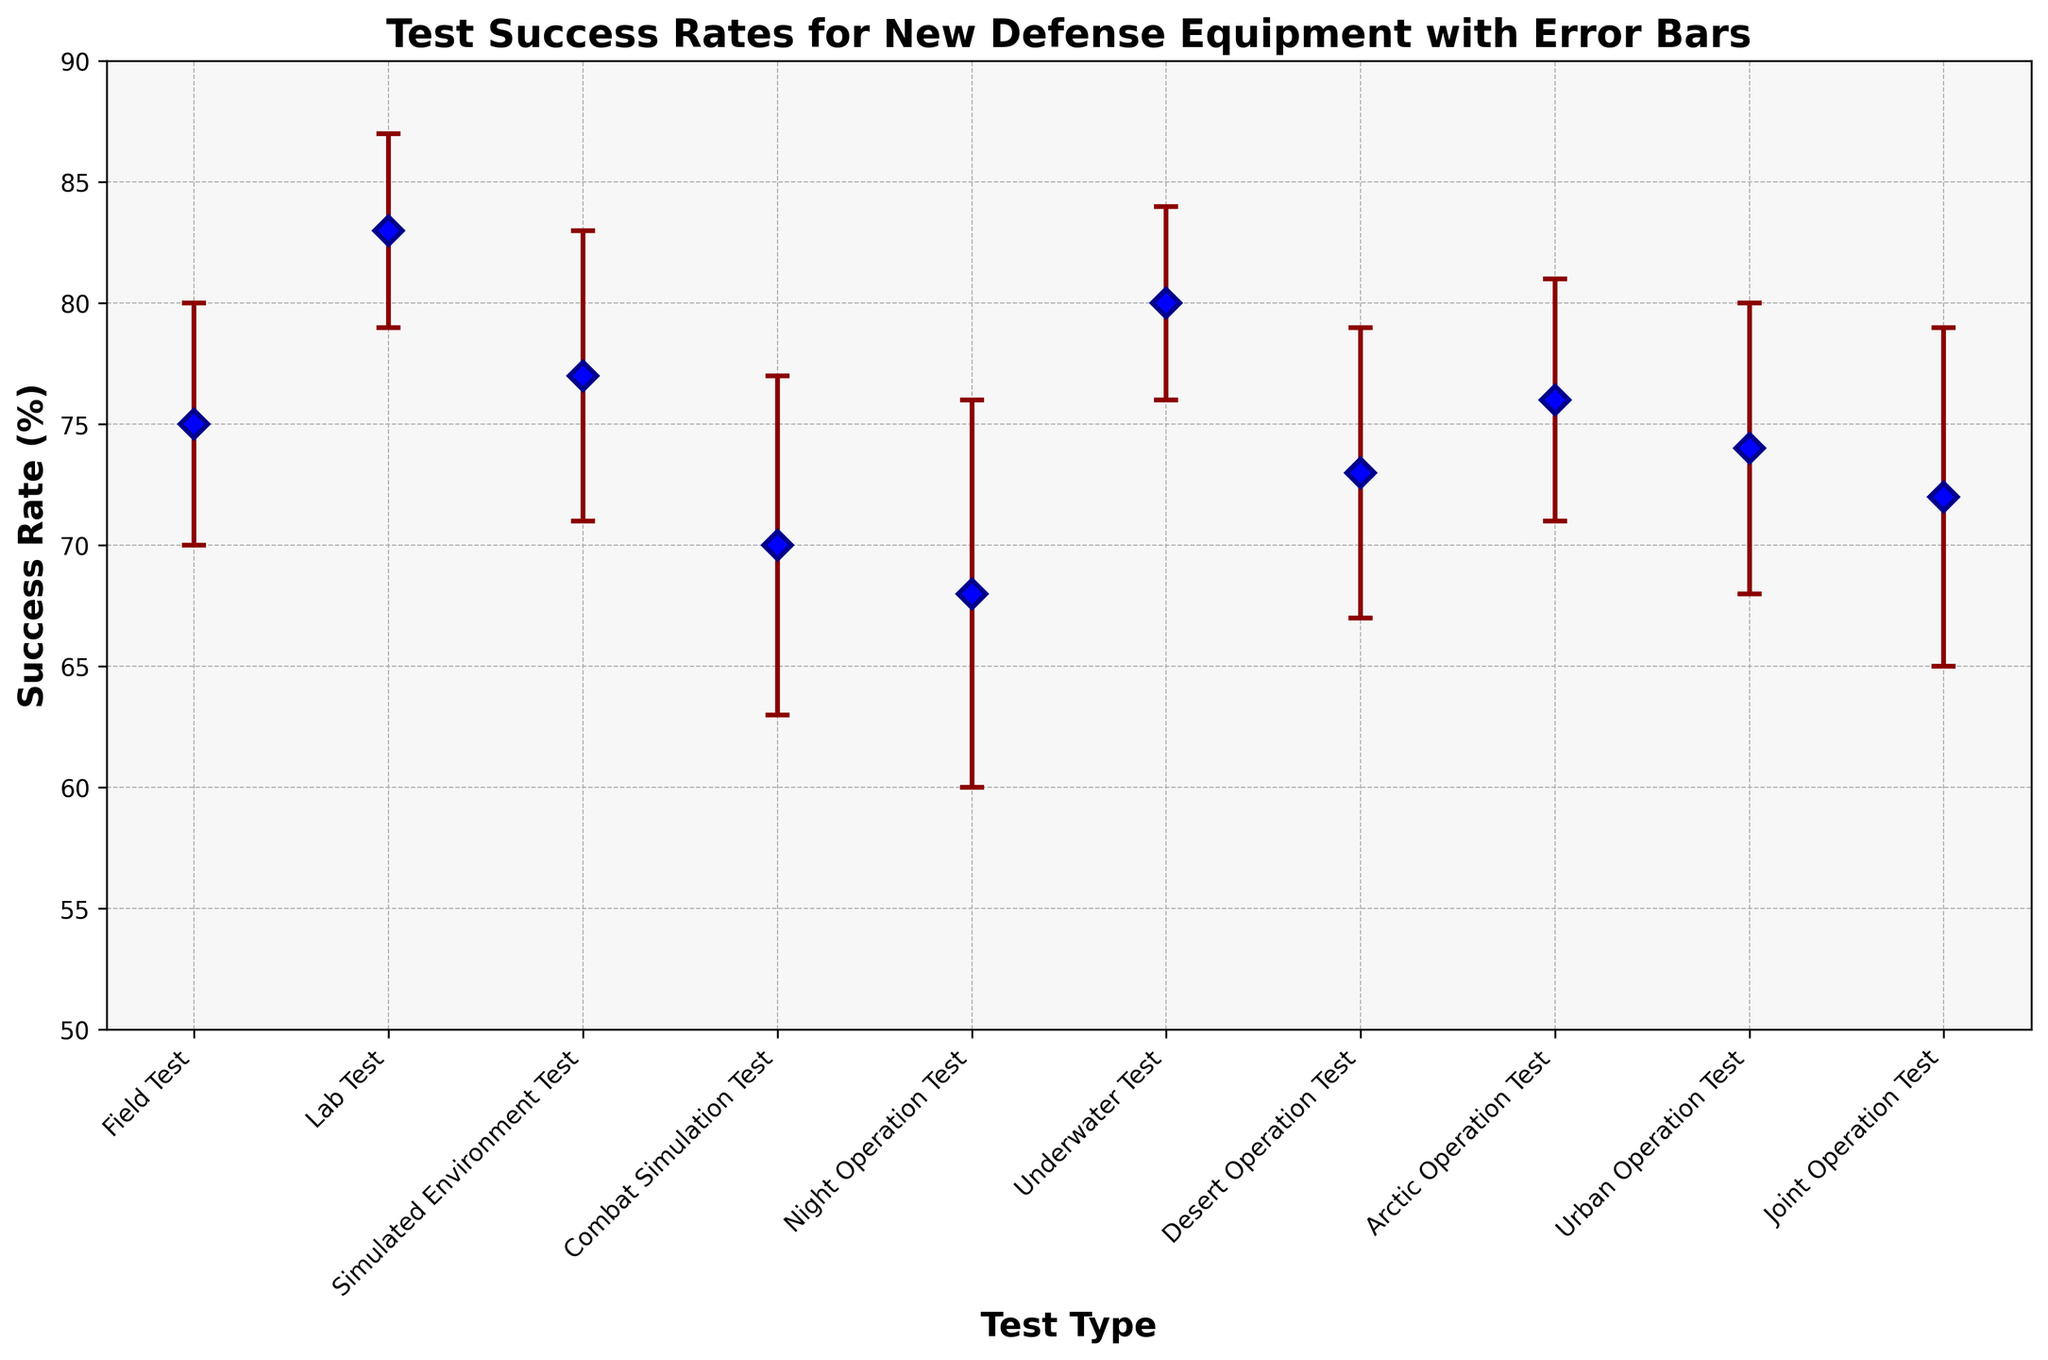What is the average success rate across all tests? Sum up the success rates for all test types (75 + 83 + 77 + 70 + 68 + 80 + 73 + 76 + 74 + 72 = 748), then divide by the number of test types (10). The average is 748/10.
Answer: 74.8 Which test type has the highest success rate? Observe the data points for success rates. The Lab Test has the highest success rate of 83%.
Answer: Lab Test What is the difference in success rates between the Lab Test and the Underwater Test? Subtract the success rate of the Underwater Test (80%) from that of the Lab Test (83%). The difference is 83 - 80.
Answer: 3% Which test type has the largest error bar? Identify the test type with the highest standard deviation represented by the error bar. The Night Operation Test has the largest standard deviation of 8%.
Answer: Night Operation Test How does the success rate for the Field Test compare to the Desert Operation Test? Compare the success rates: Field Test has 75% and Desert Operation Test has 73%. 75% is greater than 73%.
Answer: Field Test has a higher success rate What is the total range of success rates across all tests? Identify the highest and lowest success rates: Lab Test (83%) and Night Operation Test (68%). Subtract the lowest from the highest: 83 - 68.
Answer: 15% Which test types have success rates below the overall average? The overall average success rate is 74.8%. Tests with rates below this are: Combat Simulation (70%), Night Operation (68%), Desert Operation (73%), and Joint Operation (72%).
Answer: Combat Simulation, Night Operation, Desert Operation, Joint Operation What is the success rate for the Arctic Operation Test, and how does it compare to the average success rate? The Arctic Operation Test has a success rate of 76%. Compare this to the average success rate (74.8%). 76% is greater than 74.8%.
Answer: Arctic Operation Test is above average What is the combined success rate for Field and Urban Operation Tests? Add the success rates of the Field Test (75%) and Urban Operation Test (74%). The combined rate is 75 + 74.
Answer: 149% Which two test types have the closest success rates? Compare the success rates: The Field Test (75%) and Urban Operation Test (74%) have the closest rates, with a difference of just 1%.
Answer: Field Test and Urban Operation Test 